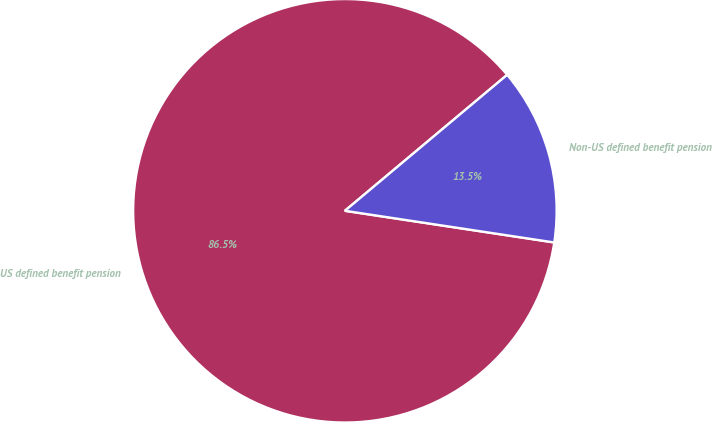<chart> <loc_0><loc_0><loc_500><loc_500><pie_chart><fcel>US defined benefit pension<fcel>Non-US defined benefit pension<nl><fcel>86.51%<fcel>13.49%<nl></chart> 